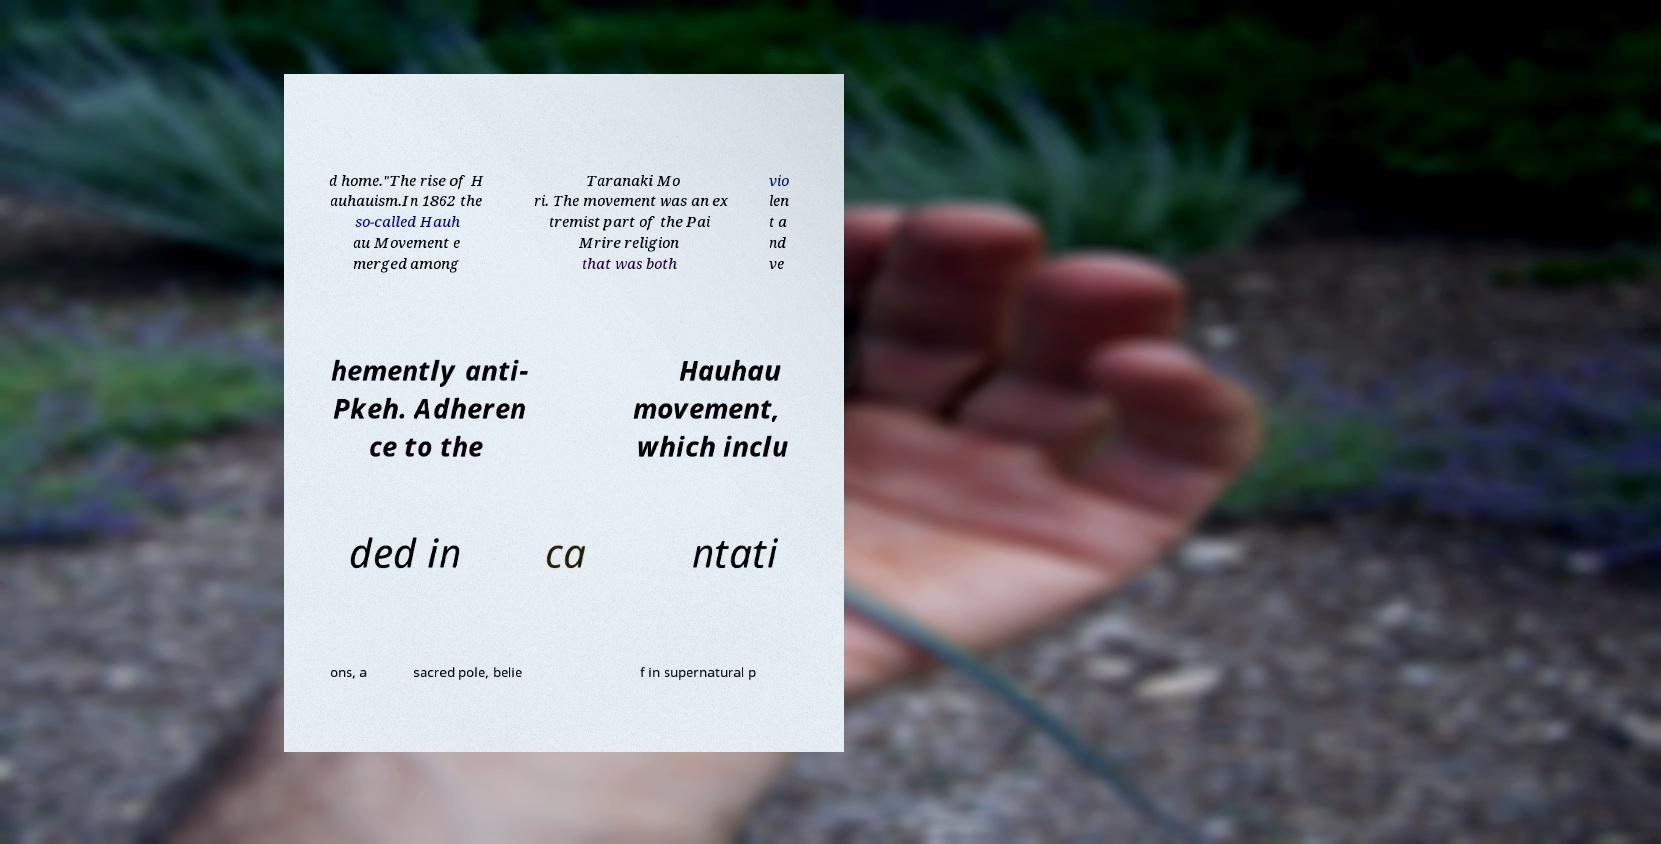Could you assist in decoding the text presented in this image and type it out clearly? d home."The rise of H auhauism.In 1862 the so-called Hauh au Movement e merged among Taranaki Mo ri. The movement was an ex tremist part of the Pai Mrire religion that was both vio len t a nd ve hemently anti- Pkeh. Adheren ce to the Hauhau movement, which inclu ded in ca ntati ons, a sacred pole, belie f in supernatural p 